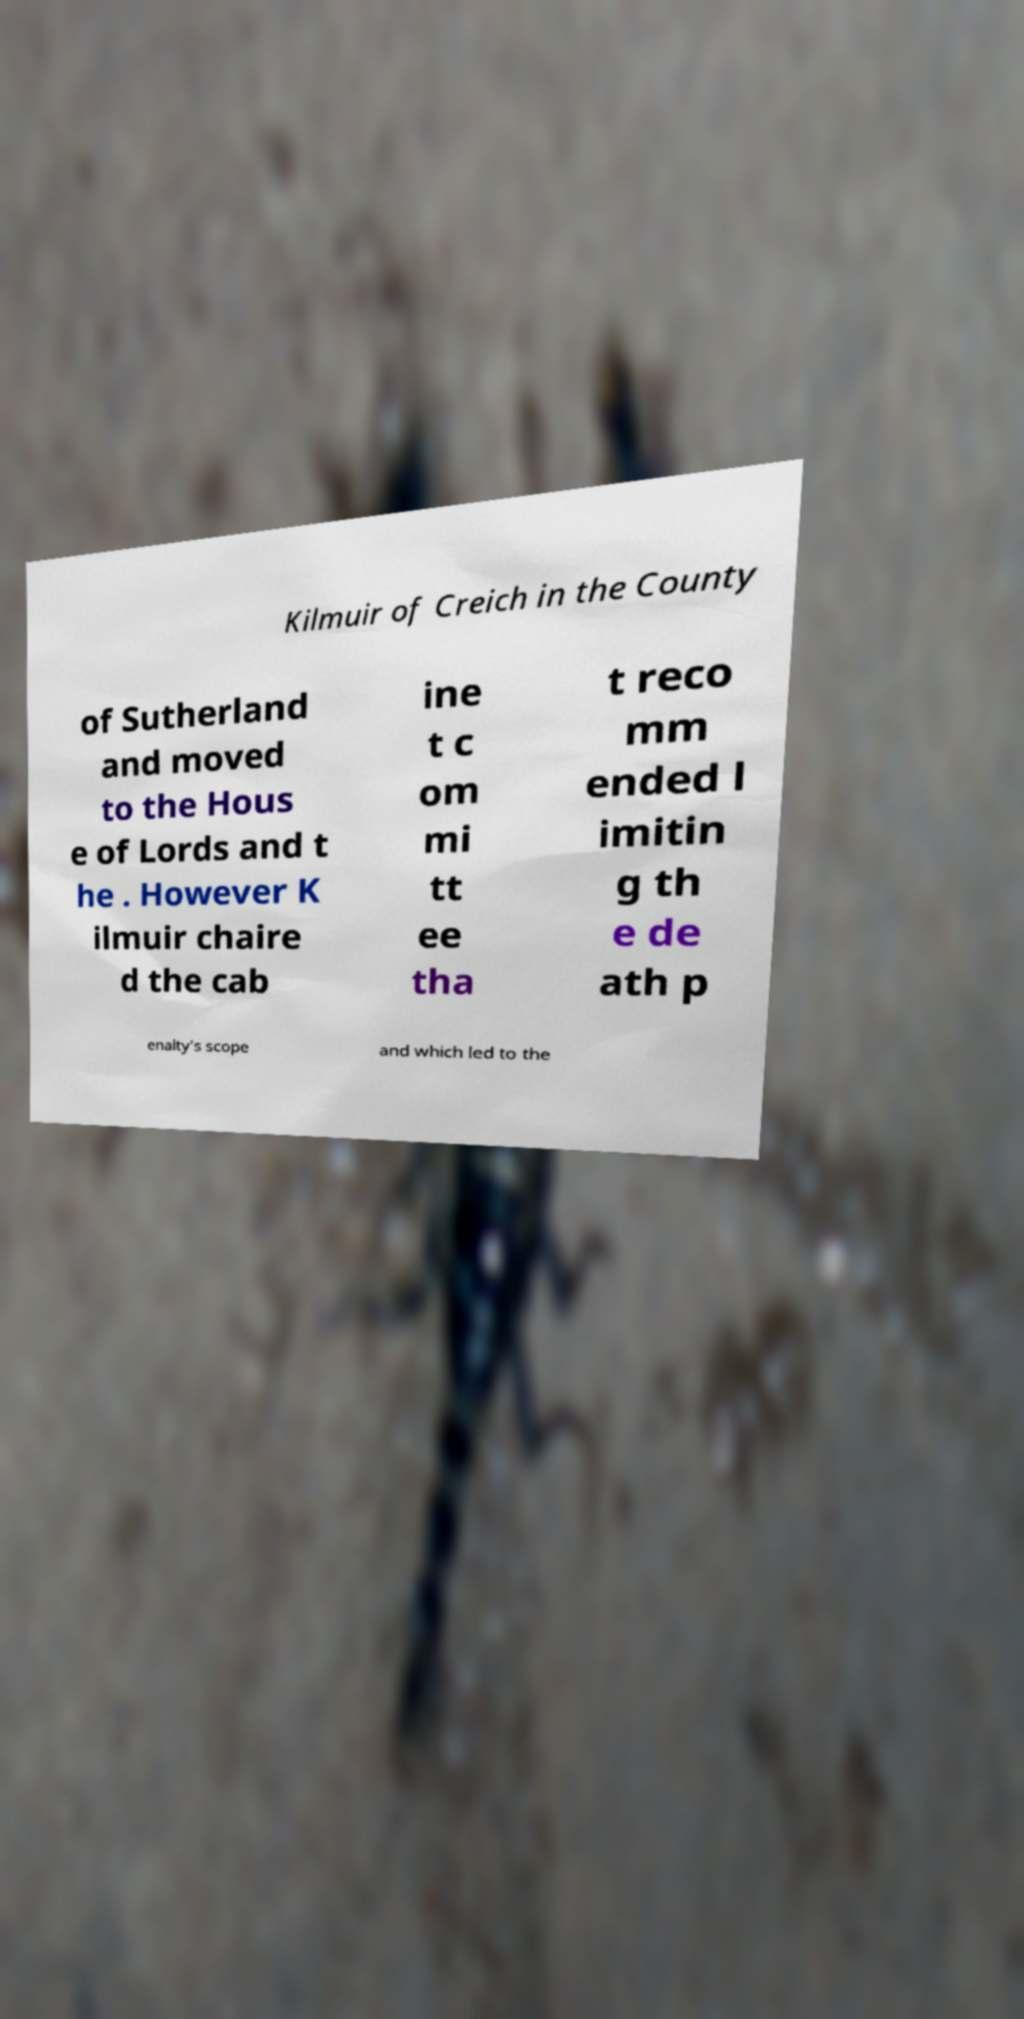Can you read and provide the text displayed in the image?This photo seems to have some interesting text. Can you extract and type it out for me? Kilmuir of Creich in the County of Sutherland and moved to the Hous e of Lords and t he . However K ilmuir chaire d the cab ine t c om mi tt ee tha t reco mm ended l imitin g th e de ath p enalty's scope and which led to the 